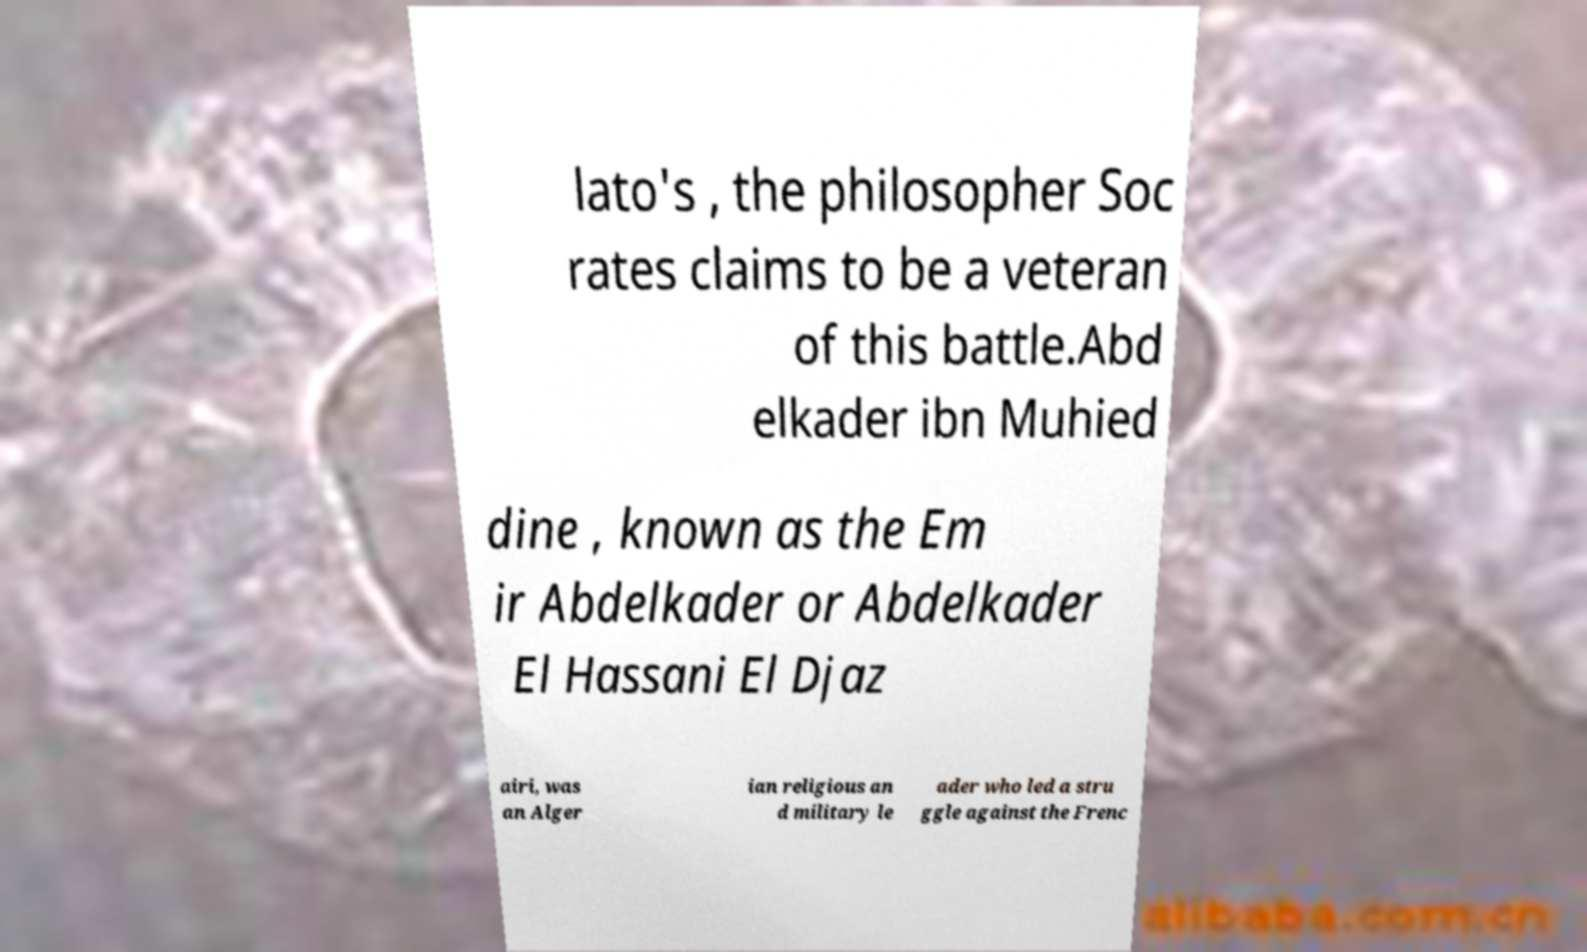Please read and relay the text visible in this image. What does it say? lato's , the philosopher Soc rates claims to be a veteran of this battle.Abd elkader ibn Muhied dine , known as the Em ir Abdelkader or Abdelkader El Hassani El Djaz airi, was an Alger ian religious an d military le ader who led a stru ggle against the Frenc 